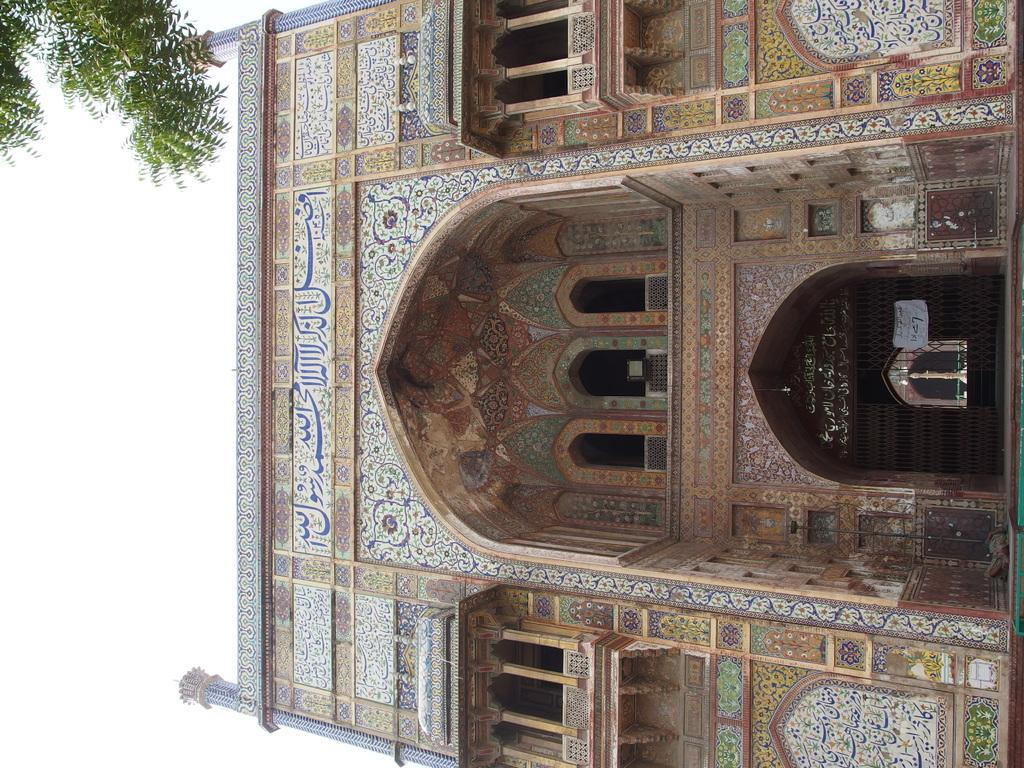What colors are used for the building in the image? The building in the image is in brown and white color. What is the main entrance to the building? There is a door in front of the building. What type of vegetation can be seen in the background of the image? There is a tree in the background of the image, and it is green. What is visible in the background of the image besides the tree? The sky is visible in the background of the image, and it is white. What type of soap is being used to clean the building in the image? There is no soap or cleaning activity depicted in the image; it only shows the building, door, tree, and sky. Can you see any rays of light coming from the building in the image? There is no mention of rays of light in the image; it only shows the building, door, tree, and sky. 